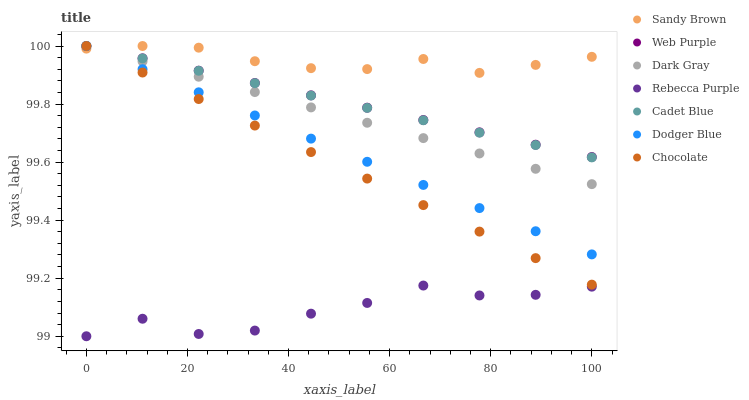Does Rebecca Purple have the minimum area under the curve?
Answer yes or no. Yes. Does Sandy Brown have the maximum area under the curve?
Answer yes or no. Yes. Does Chocolate have the minimum area under the curve?
Answer yes or no. No. Does Chocolate have the maximum area under the curve?
Answer yes or no. No. Is Web Purple the smoothest?
Answer yes or no. Yes. Is Rebecca Purple the roughest?
Answer yes or no. Yes. Is Chocolate the smoothest?
Answer yes or no. No. Is Chocolate the roughest?
Answer yes or no. No. Does Rebecca Purple have the lowest value?
Answer yes or no. Yes. Does Chocolate have the lowest value?
Answer yes or no. No. Does Sandy Brown have the highest value?
Answer yes or no. Yes. Does Rebecca Purple have the highest value?
Answer yes or no. No. Is Rebecca Purple less than Dark Gray?
Answer yes or no. Yes. Is Dodger Blue greater than Rebecca Purple?
Answer yes or no. Yes. Does Chocolate intersect Web Purple?
Answer yes or no. Yes. Is Chocolate less than Web Purple?
Answer yes or no. No. Is Chocolate greater than Web Purple?
Answer yes or no. No. Does Rebecca Purple intersect Dark Gray?
Answer yes or no. No. 